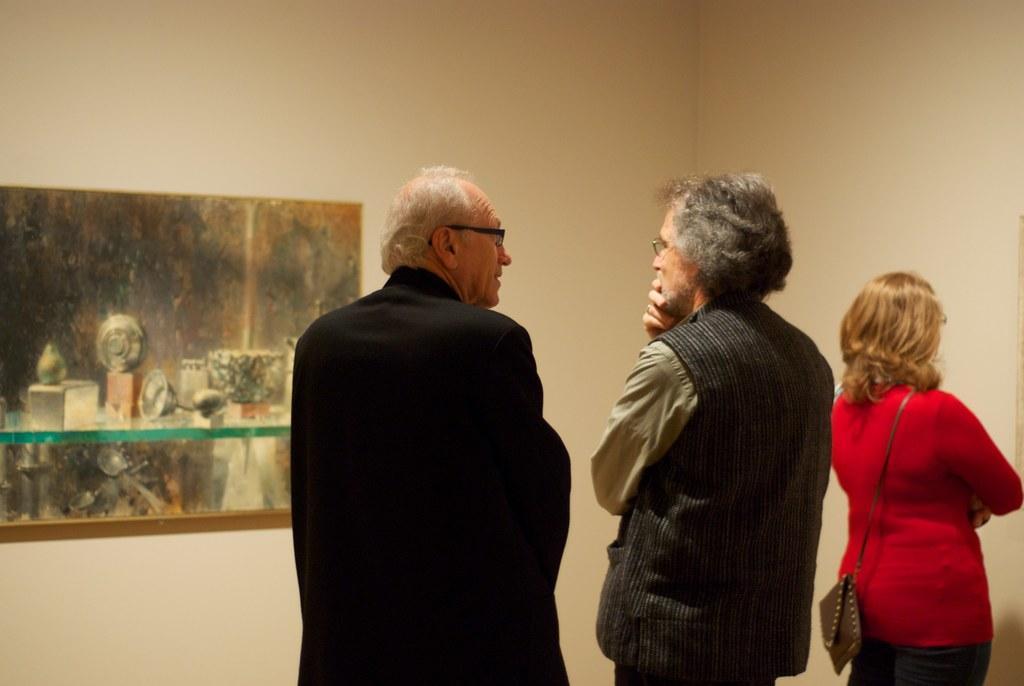Can you describe this image briefly? There are three people standing at the bottom of this image. We can see a wall in the background. There is a photo frame attached to it. 